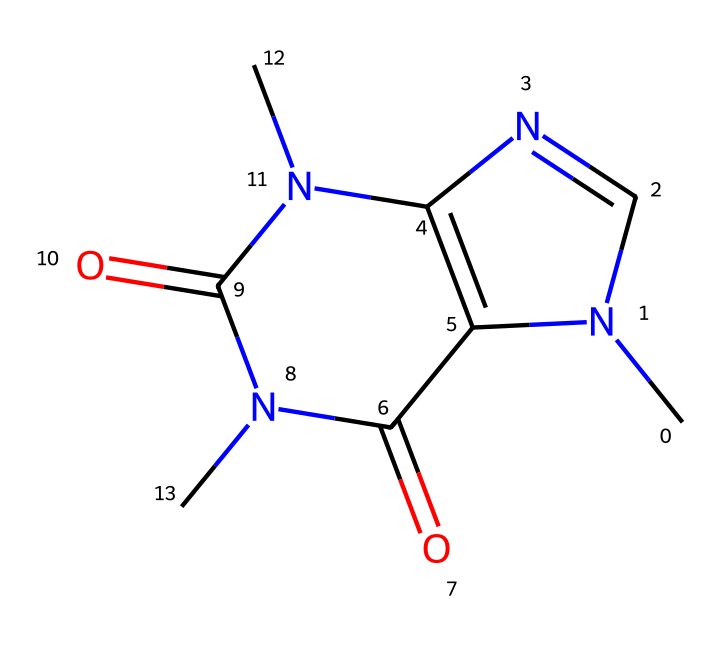What is the molecular formula of caffeine? To find the molecular formula, we count the number of carbon (C), hydrogen (H), nitrogen (N), and oxygen (O) atoms in the SMILES representation. The structure has 8 carbon atoms, 10 hydrogen atoms, 4 nitrogen atoms, and 2 oxygen atoms, which combines to form C8H10N4O2.
Answer: C8H10N4O2 How many nitrogen atoms are present in caffeine? In the SMILES representation, we identify the nitrogen symbols (N). There are four nitrogen atoms indicated in the structure.
Answer: 4 What type of compound is caffeine classified as? Caffeine is classified as a xanthine alkaloid due to its nitrogen-rich structure. The presence of multiple nitrogen atoms and methyl groups contributes to its classification as an alkaloid.
Answer: alkaloid How does caffeine primarily impact the human body? Caffeine primarily acts as a central nervous system stimulant, increasing alertness and reducing fatigue. Its structure interacts with adenosine receptors in the brain, which affects neurotransmitter release.
Answer: stimulant Why does caffeine have a bitter taste? The presence of nitrogen-containing groups in the structure is characteristic of many alkaloids, which tend to have a bitter taste. The specific arrangement of atoms contributes to this flavor profile.
Answer: bitter What functional groups are present in caffeine? The SMILES structure indicates the presence of amine (N) and carbonyl (C=O) functional groups. This combination of groups is critical for caffeine's biological activity.
Answer: amine and carbonyl 